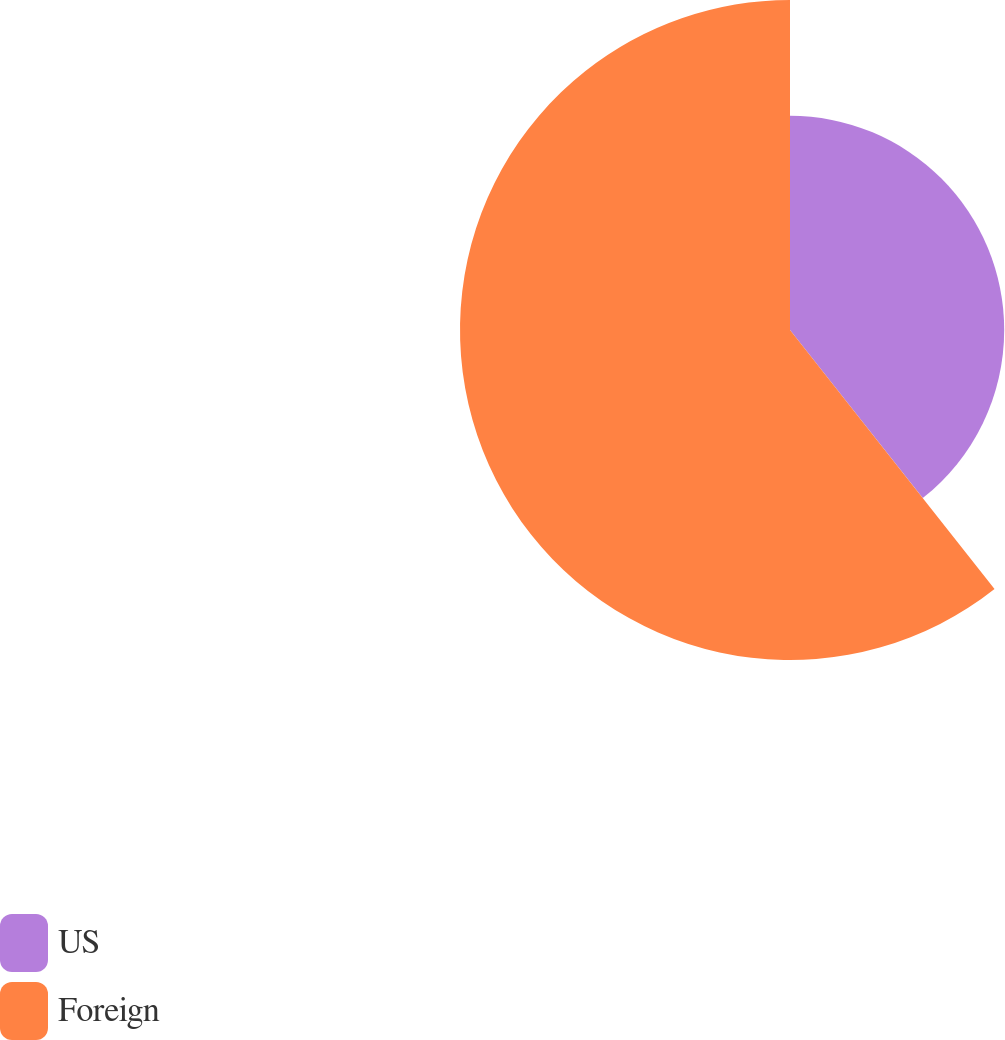<chart> <loc_0><loc_0><loc_500><loc_500><pie_chart><fcel>US<fcel>Foreign<nl><fcel>39.36%<fcel>60.64%<nl></chart> 